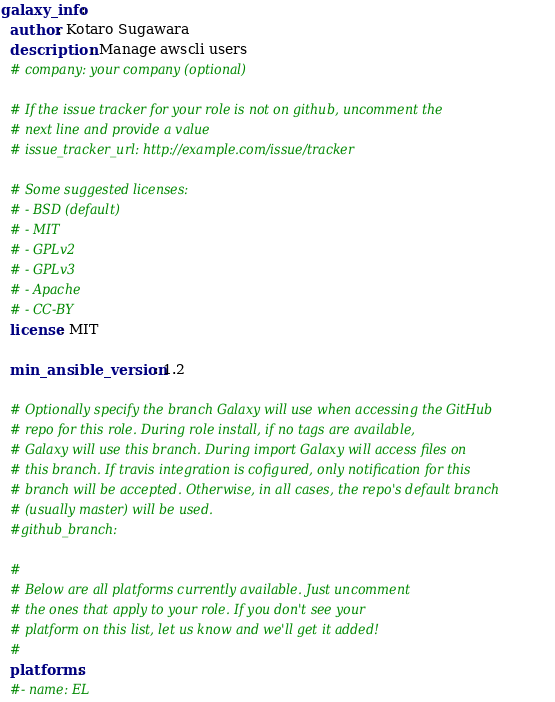Convert code to text. <code><loc_0><loc_0><loc_500><loc_500><_YAML_>galaxy_info:
  author: Kotaro Sugawara
  description: Manage awscli users
  # company: your company (optional)

  # If the issue tracker for your role is not on github, uncomment the
  # next line and provide a value
  # issue_tracker_url: http://example.com/issue/tracker

  # Some suggested licenses:
  # - BSD (default)
  # - MIT
  # - GPLv2
  # - GPLv3
  # - Apache
  # - CC-BY
  license: MIT

  min_ansible_version: 1.2

  # Optionally specify the branch Galaxy will use when accessing the GitHub
  # repo for this role. During role install, if no tags are available,
  # Galaxy will use this branch. During import Galaxy will access files on
  # this branch. If travis integration is cofigured, only notification for this
  # branch will be accepted. Otherwise, in all cases, the repo's default branch
  # (usually master) will be used.
  #github_branch:

  #
  # Below are all platforms currently available. Just uncomment
  # the ones that apply to your role. If you don't see your
  # platform on this list, let us know and we'll get it added!
  #
  platforms:
  #- name: EL</code> 